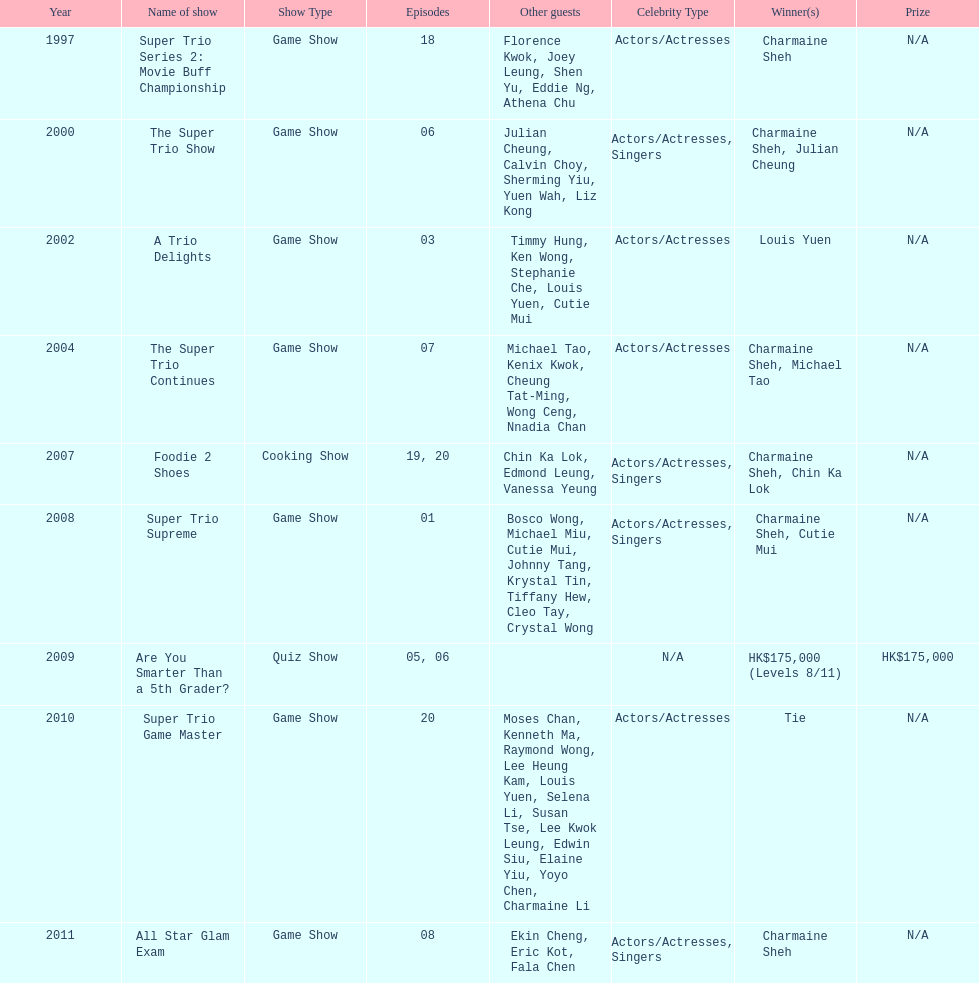How many of shows had at least 5 episodes? 7. 